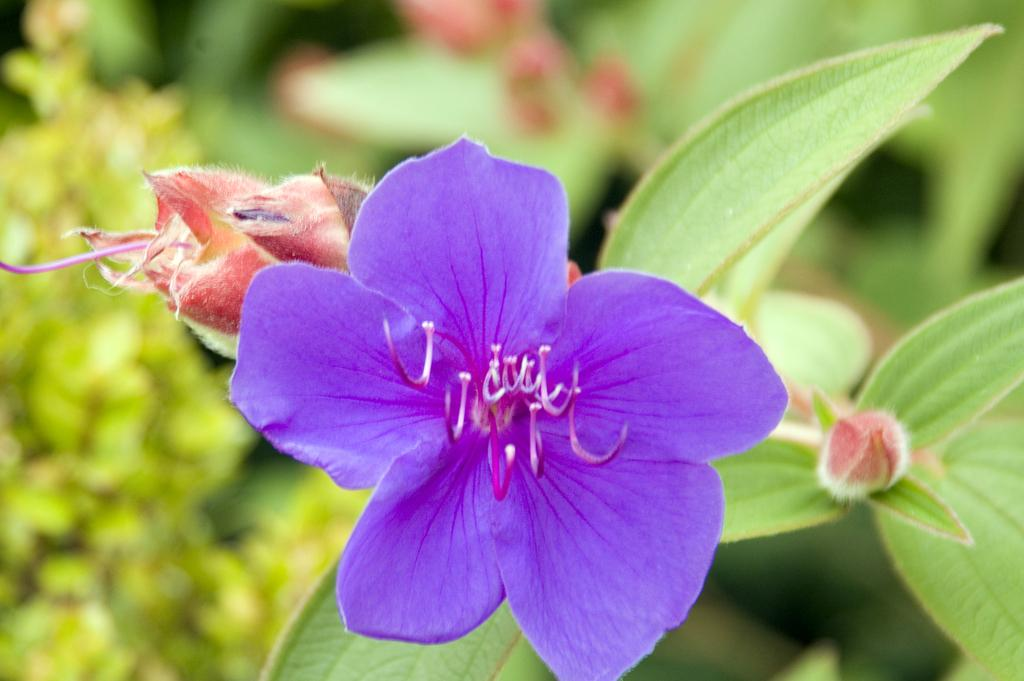What is the main subject of the image? There is a flower on a plant in the image. Can you describe the background of the image? The background of the image is blurred. How many babies are present in the image? There are no babies present in the image; it features a flower on a plant. What type of verse can be heard recited in the image? There is no verse or any sound present in the image, as it is a still photograph. 